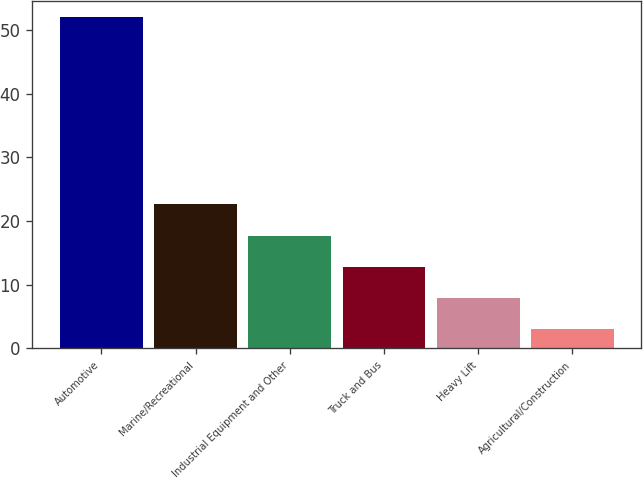Convert chart to OTSL. <chart><loc_0><loc_0><loc_500><loc_500><bar_chart><fcel>Automotive<fcel>Marine/Recreational<fcel>Industrial Equipment and Other<fcel>Truck and Bus<fcel>Heavy Lift<fcel>Agricultural/Construction<nl><fcel>52<fcel>22.6<fcel>17.7<fcel>12.8<fcel>7.9<fcel>3<nl></chart> 